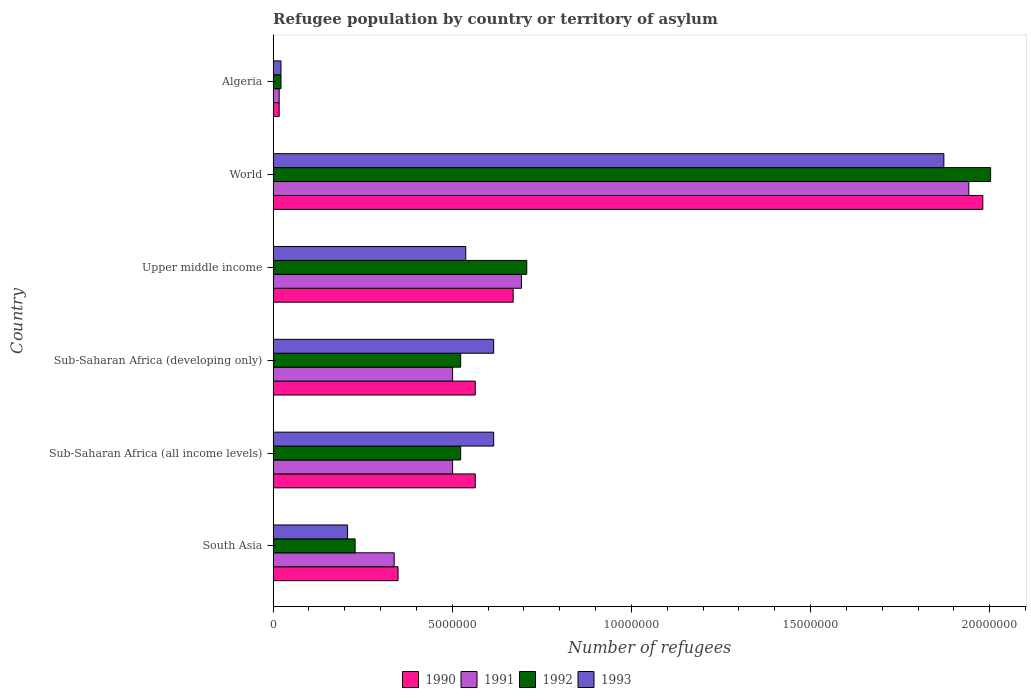How many different coloured bars are there?
Provide a short and direct response. 4. Are the number of bars per tick equal to the number of legend labels?
Make the answer very short. Yes. How many bars are there on the 2nd tick from the top?
Give a very brief answer. 4. How many bars are there on the 5th tick from the bottom?
Provide a short and direct response. 4. What is the label of the 1st group of bars from the top?
Your answer should be compact. Algeria. In how many cases, is the number of bars for a given country not equal to the number of legend labels?
Provide a succinct answer. 0. What is the number of refugees in 1991 in Sub-Saharan Africa (all income levels)?
Offer a very short reply. 5.01e+06. Across all countries, what is the maximum number of refugees in 1990?
Offer a very short reply. 1.98e+07. Across all countries, what is the minimum number of refugees in 1992?
Provide a succinct answer. 2.19e+05. In which country was the number of refugees in 1993 minimum?
Make the answer very short. Algeria. What is the total number of refugees in 1993 in the graph?
Provide a short and direct response. 3.87e+07. What is the difference between the number of refugees in 1993 in Sub-Saharan Africa (all income levels) and that in World?
Keep it short and to the point. -1.26e+07. What is the difference between the number of refugees in 1991 in Sub-Saharan Africa (all income levels) and the number of refugees in 1993 in Upper middle income?
Offer a terse response. -3.67e+05. What is the average number of refugees in 1993 per country?
Make the answer very short. 6.45e+06. In how many countries, is the number of refugees in 1992 greater than 13000000 ?
Give a very brief answer. 1. What is the ratio of the number of refugees in 1992 in Algeria to that in South Asia?
Give a very brief answer. 0.1. Is the number of refugees in 1992 in Algeria less than that in South Asia?
Offer a terse response. Yes. Is the difference between the number of refugees in 1991 in Sub-Saharan Africa (all income levels) and Sub-Saharan Africa (developing only) greater than the difference between the number of refugees in 1990 in Sub-Saharan Africa (all income levels) and Sub-Saharan Africa (developing only)?
Your response must be concise. No. What is the difference between the highest and the second highest number of refugees in 1990?
Your response must be concise. 1.31e+07. What is the difference between the highest and the lowest number of refugees in 1991?
Your answer should be compact. 1.92e+07. Is it the case that in every country, the sum of the number of refugees in 1992 and number of refugees in 1993 is greater than the number of refugees in 1990?
Your response must be concise. Yes. How many bars are there?
Provide a short and direct response. 24. Are all the bars in the graph horizontal?
Ensure brevity in your answer.  Yes. How many countries are there in the graph?
Provide a short and direct response. 6. Are the values on the major ticks of X-axis written in scientific E-notation?
Provide a succinct answer. No. Does the graph contain any zero values?
Make the answer very short. No. Does the graph contain grids?
Give a very brief answer. No. What is the title of the graph?
Ensure brevity in your answer.  Refugee population by country or territory of asylum. What is the label or title of the X-axis?
Provide a succinct answer. Number of refugees. What is the label or title of the Y-axis?
Offer a terse response. Country. What is the Number of refugees of 1990 in South Asia?
Make the answer very short. 3.49e+06. What is the Number of refugees in 1991 in South Asia?
Offer a very short reply. 3.38e+06. What is the Number of refugees in 1992 in South Asia?
Provide a short and direct response. 2.29e+06. What is the Number of refugees in 1993 in South Asia?
Provide a short and direct response. 2.08e+06. What is the Number of refugees of 1990 in Sub-Saharan Africa (all income levels)?
Give a very brief answer. 5.64e+06. What is the Number of refugees of 1991 in Sub-Saharan Africa (all income levels)?
Ensure brevity in your answer.  5.01e+06. What is the Number of refugees in 1992 in Sub-Saharan Africa (all income levels)?
Keep it short and to the point. 5.23e+06. What is the Number of refugees of 1993 in Sub-Saharan Africa (all income levels)?
Your answer should be compact. 6.16e+06. What is the Number of refugees in 1990 in Sub-Saharan Africa (developing only)?
Give a very brief answer. 5.64e+06. What is the Number of refugees in 1991 in Sub-Saharan Africa (developing only)?
Provide a short and direct response. 5.01e+06. What is the Number of refugees in 1992 in Sub-Saharan Africa (developing only)?
Your response must be concise. 5.23e+06. What is the Number of refugees of 1993 in Sub-Saharan Africa (developing only)?
Your response must be concise. 6.16e+06. What is the Number of refugees in 1990 in Upper middle income?
Your answer should be compact. 6.70e+06. What is the Number of refugees in 1991 in Upper middle income?
Provide a short and direct response. 6.93e+06. What is the Number of refugees of 1992 in Upper middle income?
Ensure brevity in your answer.  7.08e+06. What is the Number of refugees in 1993 in Upper middle income?
Keep it short and to the point. 5.38e+06. What is the Number of refugees of 1990 in World?
Ensure brevity in your answer.  1.98e+07. What is the Number of refugees in 1991 in World?
Ensure brevity in your answer.  1.94e+07. What is the Number of refugees in 1992 in World?
Provide a short and direct response. 2.00e+07. What is the Number of refugees in 1993 in World?
Offer a terse response. 1.87e+07. What is the Number of refugees in 1990 in Algeria?
Ensure brevity in your answer.  1.69e+05. What is the Number of refugees in 1991 in Algeria?
Offer a very short reply. 1.69e+05. What is the Number of refugees of 1992 in Algeria?
Make the answer very short. 2.19e+05. What is the Number of refugees in 1993 in Algeria?
Your response must be concise. 2.19e+05. Across all countries, what is the maximum Number of refugees of 1990?
Make the answer very short. 1.98e+07. Across all countries, what is the maximum Number of refugees in 1991?
Offer a very short reply. 1.94e+07. Across all countries, what is the maximum Number of refugees in 1992?
Your response must be concise. 2.00e+07. Across all countries, what is the maximum Number of refugees of 1993?
Provide a succinct answer. 1.87e+07. Across all countries, what is the minimum Number of refugees in 1990?
Offer a very short reply. 1.69e+05. Across all countries, what is the minimum Number of refugees of 1991?
Your answer should be compact. 1.69e+05. Across all countries, what is the minimum Number of refugees in 1992?
Keep it short and to the point. 2.19e+05. Across all countries, what is the minimum Number of refugees of 1993?
Your answer should be very brief. 2.19e+05. What is the total Number of refugees in 1990 in the graph?
Offer a terse response. 4.14e+07. What is the total Number of refugees in 1991 in the graph?
Give a very brief answer. 3.99e+07. What is the total Number of refugees in 1992 in the graph?
Your answer should be very brief. 4.01e+07. What is the total Number of refugees of 1993 in the graph?
Provide a succinct answer. 3.87e+07. What is the difference between the Number of refugees in 1990 in South Asia and that in Sub-Saharan Africa (all income levels)?
Provide a short and direct response. -2.15e+06. What is the difference between the Number of refugees of 1991 in South Asia and that in Sub-Saharan Africa (all income levels)?
Your response must be concise. -1.63e+06. What is the difference between the Number of refugees in 1992 in South Asia and that in Sub-Saharan Africa (all income levels)?
Offer a very short reply. -2.95e+06. What is the difference between the Number of refugees in 1993 in South Asia and that in Sub-Saharan Africa (all income levels)?
Keep it short and to the point. -4.08e+06. What is the difference between the Number of refugees of 1990 in South Asia and that in Sub-Saharan Africa (developing only)?
Make the answer very short. -2.15e+06. What is the difference between the Number of refugees of 1991 in South Asia and that in Sub-Saharan Africa (developing only)?
Your answer should be compact. -1.63e+06. What is the difference between the Number of refugees of 1992 in South Asia and that in Sub-Saharan Africa (developing only)?
Ensure brevity in your answer.  -2.95e+06. What is the difference between the Number of refugees in 1993 in South Asia and that in Sub-Saharan Africa (developing only)?
Your answer should be very brief. -4.08e+06. What is the difference between the Number of refugees in 1990 in South Asia and that in Upper middle income?
Your response must be concise. -3.21e+06. What is the difference between the Number of refugees in 1991 in South Asia and that in Upper middle income?
Keep it short and to the point. -3.55e+06. What is the difference between the Number of refugees in 1992 in South Asia and that in Upper middle income?
Offer a terse response. -4.79e+06. What is the difference between the Number of refugees of 1993 in South Asia and that in Upper middle income?
Provide a succinct answer. -3.30e+06. What is the difference between the Number of refugees in 1990 in South Asia and that in World?
Your response must be concise. -1.63e+07. What is the difference between the Number of refugees of 1991 in South Asia and that in World?
Provide a succinct answer. -1.60e+07. What is the difference between the Number of refugees of 1992 in South Asia and that in World?
Your answer should be compact. -1.77e+07. What is the difference between the Number of refugees in 1993 in South Asia and that in World?
Provide a short and direct response. -1.66e+07. What is the difference between the Number of refugees of 1990 in South Asia and that in Algeria?
Your answer should be very brief. 3.32e+06. What is the difference between the Number of refugees in 1991 in South Asia and that in Algeria?
Your response must be concise. 3.21e+06. What is the difference between the Number of refugees of 1992 in South Asia and that in Algeria?
Provide a short and direct response. 2.07e+06. What is the difference between the Number of refugees in 1993 in South Asia and that in Algeria?
Your answer should be very brief. 1.86e+06. What is the difference between the Number of refugees of 1990 in Sub-Saharan Africa (all income levels) and that in Sub-Saharan Africa (developing only)?
Ensure brevity in your answer.  0. What is the difference between the Number of refugees in 1992 in Sub-Saharan Africa (all income levels) and that in Sub-Saharan Africa (developing only)?
Give a very brief answer. 0. What is the difference between the Number of refugees in 1993 in Sub-Saharan Africa (all income levels) and that in Sub-Saharan Africa (developing only)?
Your answer should be compact. 0. What is the difference between the Number of refugees in 1990 in Sub-Saharan Africa (all income levels) and that in Upper middle income?
Your answer should be very brief. -1.06e+06. What is the difference between the Number of refugees of 1991 in Sub-Saharan Africa (all income levels) and that in Upper middle income?
Provide a short and direct response. -1.92e+06. What is the difference between the Number of refugees of 1992 in Sub-Saharan Africa (all income levels) and that in Upper middle income?
Your response must be concise. -1.84e+06. What is the difference between the Number of refugees in 1993 in Sub-Saharan Africa (all income levels) and that in Upper middle income?
Provide a succinct answer. 7.79e+05. What is the difference between the Number of refugees of 1990 in Sub-Saharan Africa (all income levels) and that in World?
Your answer should be very brief. -1.42e+07. What is the difference between the Number of refugees of 1991 in Sub-Saharan Africa (all income levels) and that in World?
Give a very brief answer. -1.44e+07. What is the difference between the Number of refugees in 1992 in Sub-Saharan Africa (all income levels) and that in World?
Provide a short and direct response. -1.48e+07. What is the difference between the Number of refugees in 1993 in Sub-Saharan Africa (all income levels) and that in World?
Provide a succinct answer. -1.26e+07. What is the difference between the Number of refugees in 1990 in Sub-Saharan Africa (all income levels) and that in Algeria?
Provide a succinct answer. 5.47e+06. What is the difference between the Number of refugees in 1991 in Sub-Saharan Africa (all income levels) and that in Algeria?
Make the answer very short. 4.84e+06. What is the difference between the Number of refugees in 1992 in Sub-Saharan Africa (all income levels) and that in Algeria?
Give a very brief answer. 5.01e+06. What is the difference between the Number of refugees in 1993 in Sub-Saharan Africa (all income levels) and that in Algeria?
Give a very brief answer. 5.94e+06. What is the difference between the Number of refugees of 1990 in Sub-Saharan Africa (developing only) and that in Upper middle income?
Keep it short and to the point. -1.06e+06. What is the difference between the Number of refugees of 1991 in Sub-Saharan Africa (developing only) and that in Upper middle income?
Keep it short and to the point. -1.92e+06. What is the difference between the Number of refugees of 1992 in Sub-Saharan Africa (developing only) and that in Upper middle income?
Give a very brief answer. -1.84e+06. What is the difference between the Number of refugees in 1993 in Sub-Saharan Africa (developing only) and that in Upper middle income?
Give a very brief answer. 7.79e+05. What is the difference between the Number of refugees of 1990 in Sub-Saharan Africa (developing only) and that in World?
Offer a very short reply. -1.42e+07. What is the difference between the Number of refugees in 1991 in Sub-Saharan Africa (developing only) and that in World?
Provide a succinct answer. -1.44e+07. What is the difference between the Number of refugees in 1992 in Sub-Saharan Africa (developing only) and that in World?
Your answer should be very brief. -1.48e+07. What is the difference between the Number of refugees of 1993 in Sub-Saharan Africa (developing only) and that in World?
Provide a succinct answer. -1.26e+07. What is the difference between the Number of refugees in 1990 in Sub-Saharan Africa (developing only) and that in Algeria?
Provide a succinct answer. 5.47e+06. What is the difference between the Number of refugees of 1991 in Sub-Saharan Africa (developing only) and that in Algeria?
Provide a short and direct response. 4.84e+06. What is the difference between the Number of refugees in 1992 in Sub-Saharan Africa (developing only) and that in Algeria?
Keep it short and to the point. 5.01e+06. What is the difference between the Number of refugees in 1993 in Sub-Saharan Africa (developing only) and that in Algeria?
Offer a very short reply. 5.94e+06. What is the difference between the Number of refugees of 1990 in Upper middle income and that in World?
Make the answer very short. -1.31e+07. What is the difference between the Number of refugees of 1991 in Upper middle income and that in World?
Ensure brevity in your answer.  -1.25e+07. What is the difference between the Number of refugees in 1992 in Upper middle income and that in World?
Your answer should be very brief. -1.29e+07. What is the difference between the Number of refugees in 1993 in Upper middle income and that in World?
Your answer should be compact. -1.33e+07. What is the difference between the Number of refugees of 1990 in Upper middle income and that in Algeria?
Provide a succinct answer. 6.53e+06. What is the difference between the Number of refugees of 1991 in Upper middle income and that in Algeria?
Ensure brevity in your answer.  6.76e+06. What is the difference between the Number of refugees in 1992 in Upper middle income and that in Algeria?
Your answer should be compact. 6.86e+06. What is the difference between the Number of refugees of 1993 in Upper middle income and that in Algeria?
Offer a very short reply. 5.16e+06. What is the difference between the Number of refugees in 1990 in World and that in Algeria?
Keep it short and to the point. 1.96e+07. What is the difference between the Number of refugees in 1991 in World and that in Algeria?
Offer a very short reply. 1.92e+07. What is the difference between the Number of refugees in 1992 in World and that in Algeria?
Offer a very short reply. 1.98e+07. What is the difference between the Number of refugees in 1993 in World and that in Algeria?
Your answer should be very brief. 1.85e+07. What is the difference between the Number of refugees of 1990 in South Asia and the Number of refugees of 1991 in Sub-Saharan Africa (all income levels)?
Ensure brevity in your answer.  -1.52e+06. What is the difference between the Number of refugees in 1990 in South Asia and the Number of refugees in 1992 in Sub-Saharan Africa (all income levels)?
Give a very brief answer. -1.75e+06. What is the difference between the Number of refugees in 1990 in South Asia and the Number of refugees in 1993 in Sub-Saharan Africa (all income levels)?
Your response must be concise. -2.67e+06. What is the difference between the Number of refugees of 1991 in South Asia and the Number of refugees of 1992 in Sub-Saharan Africa (all income levels)?
Your answer should be compact. -1.86e+06. What is the difference between the Number of refugees in 1991 in South Asia and the Number of refugees in 1993 in Sub-Saharan Africa (all income levels)?
Keep it short and to the point. -2.78e+06. What is the difference between the Number of refugees of 1992 in South Asia and the Number of refugees of 1993 in Sub-Saharan Africa (all income levels)?
Make the answer very short. -3.87e+06. What is the difference between the Number of refugees of 1990 in South Asia and the Number of refugees of 1991 in Sub-Saharan Africa (developing only)?
Your answer should be compact. -1.52e+06. What is the difference between the Number of refugees in 1990 in South Asia and the Number of refugees in 1992 in Sub-Saharan Africa (developing only)?
Keep it short and to the point. -1.75e+06. What is the difference between the Number of refugees in 1990 in South Asia and the Number of refugees in 1993 in Sub-Saharan Africa (developing only)?
Your answer should be compact. -2.67e+06. What is the difference between the Number of refugees of 1991 in South Asia and the Number of refugees of 1992 in Sub-Saharan Africa (developing only)?
Provide a short and direct response. -1.86e+06. What is the difference between the Number of refugees in 1991 in South Asia and the Number of refugees in 1993 in Sub-Saharan Africa (developing only)?
Give a very brief answer. -2.78e+06. What is the difference between the Number of refugees in 1992 in South Asia and the Number of refugees in 1993 in Sub-Saharan Africa (developing only)?
Provide a short and direct response. -3.87e+06. What is the difference between the Number of refugees in 1990 in South Asia and the Number of refugees in 1991 in Upper middle income?
Make the answer very short. -3.44e+06. What is the difference between the Number of refugees in 1990 in South Asia and the Number of refugees in 1992 in Upper middle income?
Offer a terse response. -3.59e+06. What is the difference between the Number of refugees of 1990 in South Asia and the Number of refugees of 1993 in Upper middle income?
Your answer should be very brief. -1.89e+06. What is the difference between the Number of refugees in 1991 in South Asia and the Number of refugees in 1992 in Upper middle income?
Offer a very short reply. -3.70e+06. What is the difference between the Number of refugees in 1991 in South Asia and the Number of refugees in 1993 in Upper middle income?
Provide a short and direct response. -2.00e+06. What is the difference between the Number of refugees in 1992 in South Asia and the Number of refugees in 1993 in Upper middle income?
Your answer should be very brief. -3.09e+06. What is the difference between the Number of refugees of 1990 in South Asia and the Number of refugees of 1991 in World?
Provide a short and direct response. -1.59e+07. What is the difference between the Number of refugees of 1990 in South Asia and the Number of refugees of 1992 in World?
Your response must be concise. -1.65e+07. What is the difference between the Number of refugees in 1990 in South Asia and the Number of refugees in 1993 in World?
Offer a very short reply. -1.52e+07. What is the difference between the Number of refugees in 1991 in South Asia and the Number of refugees in 1992 in World?
Your answer should be very brief. -1.66e+07. What is the difference between the Number of refugees in 1991 in South Asia and the Number of refugees in 1993 in World?
Offer a terse response. -1.53e+07. What is the difference between the Number of refugees in 1992 in South Asia and the Number of refugees in 1993 in World?
Your answer should be compact. -1.64e+07. What is the difference between the Number of refugees of 1990 in South Asia and the Number of refugees of 1991 in Algeria?
Provide a succinct answer. 3.32e+06. What is the difference between the Number of refugees in 1990 in South Asia and the Number of refugees in 1992 in Algeria?
Offer a very short reply. 3.27e+06. What is the difference between the Number of refugees of 1990 in South Asia and the Number of refugees of 1993 in Algeria?
Give a very brief answer. 3.27e+06. What is the difference between the Number of refugees of 1991 in South Asia and the Number of refugees of 1992 in Algeria?
Provide a succinct answer. 3.16e+06. What is the difference between the Number of refugees of 1991 in South Asia and the Number of refugees of 1993 in Algeria?
Ensure brevity in your answer.  3.16e+06. What is the difference between the Number of refugees in 1992 in South Asia and the Number of refugees in 1993 in Algeria?
Offer a very short reply. 2.07e+06. What is the difference between the Number of refugees of 1990 in Sub-Saharan Africa (all income levels) and the Number of refugees of 1991 in Sub-Saharan Africa (developing only)?
Give a very brief answer. 6.33e+05. What is the difference between the Number of refugees in 1990 in Sub-Saharan Africa (all income levels) and the Number of refugees in 1992 in Sub-Saharan Africa (developing only)?
Give a very brief answer. 4.07e+05. What is the difference between the Number of refugees of 1990 in Sub-Saharan Africa (all income levels) and the Number of refugees of 1993 in Sub-Saharan Africa (developing only)?
Offer a terse response. -5.14e+05. What is the difference between the Number of refugees of 1991 in Sub-Saharan Africa (all income levels) and the Number of refugees of 1992 in Sub-Saharan Africa (developing only)?
Keep it short and to the point. -2.25e+05. What is the difference between the Number of refugees in 1991 in Sub-Saharan Africa (all income levels) and the Number of refugees in 1993 in Sub-Saharan Africa (developing only)?
Your answer should be compact. -1.15e+06. What is the difference between the Number of refugees in 1992 in Sub-Saharan Africa (all income levels) and the Number of refugees in 1993 in Sub-Saharan Africa (developing only)?
Provide a short and direct response. -9.21e+05. What is the difference between the Number of refugees in 1990 in Sub-Saharan Africa (all income levels) and the Number of refugees in 1991 in Upper middle income?
Provide a succinct answer. -1.29e+06. What is the difference between the Number of refugees of 1990 in Sub-Saharan Africa (all income levels) and the Number of refugees of 1992 in Upper middle income?
Give a very brief answer. -1.44e+06. What is the difference between the Number of refugees in 1990 in Sub-Saharan Africa (all income levels) and the Number of refugees in 1993 in Upper middle income?
Give a very brief answer. 2.65e+05. What is the difference between the Number of refugees of 1991 in Sub-Saharan Africa (all income levels) and the Number of refugees of 1992 in Upper middle income?
Offer a terse response. -2.07e+06. What is the difference between the Number of refugees in 1991 in Sub-Saharan Africa (all income levels) and the Number of refugees in 1993 in Upper middle income?
Your response must be concise. -3.67e+05. What is the difference between the Number of refugees in 1992 in Sub-Saharan Africa (all income levels) and the Number of refugees in 1993 in Upper middle income?
Provide a succinct answer. -1.42e+05. What is the difference between the Number of refugees in 1990 in Sub-Saharan Africa (all income levels) and the Number of refugees in 1991 in World?
Make the answer very short. -1.38e+07. What is the difference between the Number of refugees in 1990 in Sub-Saharan Africa (all income levels) and the Number of refugees in 1992 in World?
Keep it short and to the point. -1.44e+07. What is the difference between the Number of refugees of 1990 in Sub-Saharan Africa (all income levels) and the Number of refugees of 1993 in World?
Make the answer very short. -1.31e+07. What is the difference between the Number of refugees in 1991 in Sub-Saharan Africa (all income levels) and the Number of refugees in 1992 in World?
Your answer should be compact. -1.50e+07. What is the difference between the Number of refugees in 1991 in Sub-Saharan Africa (all income levels) and the Number of refugees in 1993 in World?
Provide a short and direct response. -1.37e+07. What is the difference between the Number of refugees of 1992 in Sub-Saharan Africa (all income levels) and the Number of refugees of 1993 in World?
Your response must be concise. -1.35e+07. What is the difference between the Number of refugees of 1990 in Sub-Saharan Africa (all income levels) and the Number of refugees of 1991 in Algeria?
Your answer should be compact. 5.47e+06. What is the difference between the Number of refugees in 1990 in Sub-Saharan Africa (all income levels) and the Number of refugees in 1992 in Algeria?
Your response must be concise. 5.42e+06. What is the difference between the Number of refugees in 1990 in Sub-Saharan Africa (all income levels) and the Number of refugees in 1993 in Algeria?
Offer a terse response. 5.42e+06. What is the difference between the Number of refugees in 1991 in Sub-Saharan Africa (all income levels) and the Number of refugees in 1992 in Algeria?
Your answer should be compact. 4.79e+06. What is the difference between the Number of refugees in 1991 in Sub-Saharan Africa (all income levels) and the Number of refugees in 1993 in Algeria?
Your response must be concise. 4.79e+06. What is the difference between the Number of refugees in 1992 in Sub-Saharan Africa (all income levels) and the Number of refugees in 1993 in Algeria?
Keep it short and to the point. 5.02e+06. What is the difference between the Number of refugees in 1990 in Sub-Saharan Africa (developing only) and the Number of refugees in 1991 in Upper middle income?
Your response must be concise. -1.29e+06. What is the difference between the Number of refugees of 1990 in Sub-Saharan Africa (developing only) and the Number of refugees of 1992 in Upper middle income?
Ensure brevity in your answer.  -1.44e+06. What is the difference between the Number of refugees of 1990 in Sub-Saharan Africa (developing only) and the Number of refugees of 1993 in Upper middle income?
Your answer should be very brief. 2.65e+05. What is the difference between the Number of refugees of 1991 in Sub-Saharan Africa (developing only) and the Number of refugees of 1992 in Upper middle income?
Provide a short and direct response. -2.07e+06. What is the difference between the Number of refugees in 1991 in Sub-Saharan Africa (developing only) and the Number of refugees in 1993 in Upper middle income?
Offer a very short reply. -3.67e+05. What is the difference between the Number of refugees in 1992 in Sub-Saharan Africa (developing only) and the Number of refugees in 1993 in Upper middle income?
Ensure brevity in your answer.  -1.42e+05. What is the difference between the Number of refugees in 1990 in Sub-Saharan Africa (developing only) and the Number of refugees in 1991 in World?
Offer a terse response. -1.38e+07. What is the difference between the Number of refugees in 1990 in Sub-Saharan Africa (developing only) and the Number of refugees in 1992 in World?
Your answer should be very brief. -1.44e+07. What is the difference between the Number of refugees of 1990 in Sub-Saharan Africa (developing only) and the Number of refugees of 1993 in World?
Offer a very short reply. -1.31e+07. What is the difference between the Number of refugees in 1991 in Sub-Saharan Africa (developing only) and the Number of refugees in 1992 in World?
Give a very brief answer. -1.50e+07. What is the difference between the Number of refugees of 1991 in Sub-Saharan Africa (developing only) and the Number of refugees of 1993 in World?
Give a very brief answer. -1.37e+07. What is the difference between the Number of refugees of 1992 in Sub-Saharan Africa (developing only) and the Number of refugees of 1993 in World?
Offer a very short reply. -1.35e+07. What is the difference between the Number of refugees of 1990 in Sub-Saharan Africa (developing only) and the Number of refugees of 1991 in Algeria?
Give a very brief answer. 5.47e+06. What is the difference between the Number of refugees of 1990 in Sub-Saharan Africa (developing only) and the Number of refugees of 1992 in Algeria?
Make the answer very short. 5.42e+06. What is the difference between the Number of refugees in 1990 in Sub-Saharan Africa (developing only) and the Number of refugees in 1993 in Algeria?
Keep it short and to the point. 5.42e+06. What is the difference between the Number of refugees in 1991 in Sub-Saharan Africa (developing only) and the Number of refugees in 1992 in Algeria?
Ensure brevity in your answer.  4.79e+06. What is the difference between the Number of refugees of 1991 in Sub-Saharan Africa (developing only) and the Number of refugees of 1993 in Algeria?
Your response must be concise. 4.79e+06. What is the difference between the Number of refugees of 1992 in Sub-Saharan Africa (developing only) and the Number of refugees of 1993 in Algeria?
Your response must be concise. 5.02e+06. What is the difference between the Number of refugees of 1990 in Upper middle income and the Number of refugees of 1991 in World?
Offer a terse response. -1.27e+07. What is the difference between the Number of refugees of 1990 in Upper middle income and the Number of refugees of 1992 in World?
Offer a very short reply. -1.33e+07. What is the difference between the Number of refugees of 1990 in Upper middle income and the Number of refugees of 1993 in World?
Offer a very short reply. -1.20e+07. What is the difference between the Number of refugees of 1991 in Upper middle income and the Number of refugees of 1992 in World?
Offer a very short reply. -1.31e+07. What is the difference between the Number of refugees of 1991 in Upper middle income and the Number of refugees of 1993 in World?
Provide a short and direct response. -1.18e+07. What is the difference between the Number of refugees in 1992 in Upper middle income and the Number of refugees in 1993 in World?
Ensure brevity in your answer.  -1.16e+07. What is the difference between the Number of refugees of 1990 in Upper middle income and the Number of refugees of 1991 in Algeria?
Provide a short and direct response. 6.53e+06. What is the difference between the Number of refugees in 1990 in Upper middle income and the Number of refugees in 1992 in Algeria?
Keep it short and to the point. 6.48e+06. What is the difference between the Number of refugees of 1990 in Upper middle income and the Number of refugees of 1993 in Algeria?
Your response must be concise. 6.48e+06. What is the difference between the Number of refugees in 1991 in Upper middle income and the Number of refugees in 1992 in Algeria?
Offer a terse response. 6.71e+06. What is the difference between the Number of refugees in 1991 in Upper middle income and the Number of refugees in 1993 in Algeria?
Give a very brief answer. 6.71e+06. What is the difference between the Number of refugees of 1992 in Upper middle income and the Number of refugees of 1993 in Algeria?
Your answer should be compact. 6.86e+06. What is the difference between the Number of refugees of 1990 in World and the Number of refugees of 1991 in Algeria?
Provide a short and direct response. 1.96e+07. What is the difference between the Number of refugees in 1990 in World and the Number of refugees in 1992 in Algeria?
Offer a terse response. 1.96e+07. What is the difference between the Number of refugees of 1990 in World and the Number of refugees of 1993 in Algeria?
Make the answer very short. 1.96e+07. What is the difference between the Number of refugees in 1991 in World and the Number of refugees in 1992 in Algeria?
Provide a short and direct response. 1.92e+07. What is the difference between the Number of refugees of 1991 in World and the Number of refugees of 1993 in Algeria?
Provide a succinct answer. 1.92e+07. What is the difference between the Number of refugees in 1992 in World and the Number of refugees in 1993 in Algeria?
Make the answer very short. 1.98e+07. What is the average Number of refugees of 1990 per country?
Make the answer very short. 6.91e+06. What is the average Number of refugees of 1991 per country?
Make the answer very short. 6.65e+06. What is the average Number of refugees of 1992 per country?
Your answer should be compact. 6.68e+06. What is the average Number of refugees of 1993 per country?
Your response must be concise. 6.45e+06. What is the difference between the Number of refugees of 1990 and Number of refugees of 1991 in South Asia?
Provide a short and direct response. 1.08e+05. What is the difference between the Number of refugees of 1990 and Number of refugees of 1992 in South Asia?
Offer a terse response. 1.20e+06. What is the difference between the Number of refugees in 1990 and Number of refugees in 1993 in South Asia?
Offer a very short reply. 1.41e+06. What is the difference between the Number of refugees in 1991 and Number of refugees in 1992 in South Asia?
Provide a succinct answer. 1.09e+06. What is the difference between the Number of refugees in 1991 and Number of refugees in 1993 in South Asia?
Your response must be concise. 1.30e+06. What is the difference between the Number of refugees of 1992 and Number of refugees of 1993 in South Asia?
Give a very brief answer. 2.10e+05. What is the difference between the Number of refugees of 1990 and Number of refugees of 1991 in Sub-Saharan Africa (all income levels)?
Keep it short and to the point. 6.33e+05. What is the difference between the Number of refugees in 1990 and Number of refugees in 1992 in Sub-Saharan Africa (all income levels)?
Provide a short and direct response. 4.07e+05. What is the difference between the Number of refugees of 1990 and Number of refugees of 1993 in Sub-Saharan Africa (all income levels)?
Your answer should be very brief. -5.14e+05. What is the difference between the Number of refugees of 1991 and Number of refugees of 1992 in Sub-Saharan Africa (all income levels)?
Provide a succinct answer. -2.25e+05. What is the difference between the Number of refugees in 1991 and Number of refugees in 1993 in Sub-Saharan Africa (all income levels)?
Your response must be concise. -1.15e+06. What is the difference between the Number of refugees in 1992 and Number of refugees in 1993 in Sub-Saharan Africa (all income levels)?
Keep it short and to the point. -9.21e+05. What is the difference between the Number of refugees of 1990 and Number of refugees of 1991 in Sub-Saharan Africa (developing only)?
Your response must be concise. 6.33e+05. What is the difference between the Number of refugees in 1990 and Number of refugees in 1992 in Sub-Saharan Africa (developing only)?
Keep it short and to the point. 4.07e+05. What is the difference between the Number of refugees of 1990 and Number of refugees of 1993 in Sub-Saharan Africa (developing only)?
Make the answer very short. -5.14e+05. What is the difference between the Number of refugees of 1991 and Number of refugees of 1992 in Sub-Saharan Africa (developing only)?
Offer a very short reply. -2.25e+05. What is the difference between the Number of refugees in 1991 and Number of refugees in 1993 in Sub-Saharan Africa (developing only)?
Your answer should be very brief. -1.15e+06. What is the difference between the Number of refugees of 1992 and Number of refugees of 1993 in Sub-Saharan Africa (developing only)?
Keep it short and to the point. -9.21e+05. What is the difference between the Number of refugees in 1990 and Number of refugees in 1991 in Upper middle income?
Ensure brevity in your answer.  -2.32e+05. What is the difference between the Number of refugees in 1990 and Number of refugees in 1992 in Upper middle income?
Keep it short and to the point. -3.79e+05. What is the difference between the Number of refugees in 1990 and Number of refugees in 1993 in Upper middle income?
Provide a short and direct response. 1.32e+06. What is the difference between the Number of refugees of 1991 and Number of refugees of 1992 in Upper middle income?
Offer a very short reply. -1.47e+05. What is the difference between the Number of refugees of 1991 and Number of refugees of 1993 in Upper middle income?
Make the answer very short. 1.56e+06. What is the difference between the Number of refugees in 1992 and Number of refugees in 1993 in Upper middle income?
Offer a very short reply. 1.70e+06. What is the difference between the Number of refugees of 1990 and Number of refugees of 1991 in World?
Keep it short and to the point. 3.91e+05. What is the difference between the Number of refugees in 1990 and Number of refugees in 1992 in World?
Your response must be concise. -2.18e+05. What is the difference between the Number of refugees in 1990 and Number of refugees in 1993 in World?
Provide a short and direct response. 1.09e+06. What is the difference between the Number of refugees of 1991 and Number of refugees of 1992 in World?
Offer a very short reply. -6.09e+05. What is the difference between the Number of refugees in 1991 and Number of refugees in 1993 in World?
Provide a short and direct response. 6.96e+05. What is the difference between the Number of refugees of 1992 and Number of refugees of 1993 in World?
Keep it short and to the point. 1.30e+06. What is the difference between the Number of refugees of 1990 and Number of refugees of 1991 in Algeria?
Keep it short and to the point. -14. What is the difference between the Number of refugees in 1990 and Number of refugees in 1992 in Algeria?
Keep it short and to the point. -5.02e+04. What is the difference between the Number of refugees of 1990 and Number of refugees of 1993 in Algeria?
Your answer should be very brief. -5.00e+04. What is the difference between the Number of refugees in 1991 and Number of refugees in 1992 in Algeria?
Keep it short and to the point. -5.02e+04. What is the difference between the Number of refugees in 1991 and Number of refugees in 1993 in Algeria?
Your response must be concise. -4.99e+04. What is the difference between the Number of refugees in 1992 and Number of refugees in 1993 in Algeria?
Offer a terse response. 247. What is the ratio of the Number of refugees of 1990 in South Asia to that in Sub-Saharan Africa (all income levels)?
Provide a succinct answer. 0.62. What is the ratio of the Number of refugees in 1991 in South Asia to that in Sub-Saharan Africa (all income levels)?
Make the answer very short. 0.67. What is the ratio of the Number of refugees of 1992 in South Asia to that in Sub-Saharan Africa (all income levels)?
Provide a succinct answer. 0.44. What is the ratio of the Number of refugees in 1993 in South Asia to that in Sub-Saharan Africa (all income levels)?
Ensure brevity in your answer.  0.34. What is the ratio of the Number of refugees of 1990 in South Asia to that in Sub-Saharan Africa (developing only)?
Your response must be concise. 0.62. What is the ratio of the Number of refugees of 1991 in South Asia to that in Sub-Saharan Africa (developing only)?
Your answer should be very brief. 0.67. What is the ratio of the Number of refugees in 1992 in South Asia to that in Sub-Saharan Africa (developing only)?
Provide a succinct answer. 0.44. What is the ratio of the Number of refugees of 1993 in South Asia to that in Sub-Saharan Africa (developing only)?
Offer a very short reply. 0.34. What is the ratio of the Number of refugees of 1990 in South Asia to that in Upper middle income?
Make the answer very short. 0.52. What is the ratio of the Number of refugees of 1991 in South Asia to that in Upper middle income?
Your response must be concise. 0.49. What is the ratio of the Number of refugees of 1992 in South Asia to that in Upper middle income?
Your answer should be compact. 0.32. What is the ratio of the Number of refugees of 1993 in South Asia to that in Upper middle income?
Offer a very short reply. 0.39. What is the ratio of the Number of refugees in 1990 in South Asia to that in World?
Your response must be concise. 0.18. What is the ratio of the Number of refugees in 1991 in South Asia to that in World?
Ensure brevity in your answer.  0.17. What is the ratio of the Number of refugees in 1992 in South Asia to that in World?
Offer a terse response. 0.11. What is the ratio of the Number of refugees of 1993 in South Asia to that in World?
Keep it short and to the point. 0.11. What is the ratio of the Number of refugees in 1990 in South Asia to that in Algeria?
Offer a terse response. 20.62. What is the ratio of the Number of refugees of 1991 in South Asia to that in Algeria?
Your answer should be compact. 19.98. What is the ratio of the Number of refugees in 1992 in South Asia to that in Algeria?
Give a very brief answer. 10.43. What is the ratio of the Number of refugees in 1993 in South Asia to that in Algeria?
Give a very brief answer. 9.49. What is the ratio of the Number of refugees of 1992 in Sub-Saharan Africa (all income levels) to that in Sub-Saharan Africa (developing only)?
Offer a terse response. 1. What is the ratio of the Number of refugees in 1990 in Sub-Saharan Africa (all income levels) to that in Upper middle income?
Your answer should be very brief. 0.84. What is the ratio of the Number of refugees in 1991 in Sub-Saharan Africa (all income levels) to that in Upper middle income?
Your answer should be compact. 0.72. What is the ratio of the Number of refugees of 1992 in Sub-Saharan Africa (all income levels) to that in Upper middle income?
Offer a very short reply. 0.74. What is the ratio of the Number of refugees in 1993 in Sub-Saharan Africa (all income levels) to that in Upper middle income?
Offer a very short reply. 1.15. What is the ratio of the Number of refugees of 1990 in Sub-Saharan Africa (all income levels) to that in World?
Provide a succinct answer. 0.28. What is the ratio of the Number of refugees of 1991 in Sub-Saharan Africa (all income levels) to that in World?
Your answer should be very brief. 0.26. What is the ratio of the Number of refugees in 1992 in Sub-Saharan Africa (all income levels) to that in World?
Give a very brief answer. 0.26. What is the ratio of the Number of refugees of 1993 in Sub-Saharan Africa (all income levels) to that in World?
Offer a very short reply. 0.33. What is the ratio of the Number of refugees of 1990 in Sub-Saharan Africa (all income levels) to that in Algeria?
Make the answer very short. 33.36. What is the ratio of the Number of refugees in 1991 in Sub-Saharan Africa (all income levels) to that in Algeria?
Offer a very short reply. 29.62. What is the ratio of the Number of refugees of 1992 in Sub-Saharan Africa (all income levels) to that in Algeria?
Provide a succinct answer. 23.87. What is the ratio of the Number of refugees of 1993 in Sub-Saharan Africa (all income levels) to that in Algeria?
Ensure brevity in your answer.  28.1. What is the ratio of the Number of refugees of 1990 in Sub-Saharan Africa (developing only) to that in Upper middle income?
Provide a succinct answer. 0.84. What is the ratio of the Number of refugees of 1991 in Sub-Saharan Africa (developing only) to that in Upper middle income?
Your response must be concise. 0.72. What is the ratio of the Number of refugees in 1992 in Sub-Saharan Africa (developing only) to that in Upper middle income?
Provide a succinct answer. 0.74. What is the ratio of the Number of refugees in 1993 in Sub-Saharan Africa (developing only) to that in Upper middle income?
Provide a short and direct response. 1.15. What is the ratio of the Number of refugees in 1990 in Sub-Saharan Africa (developing only) to that in World?
Your answer should be very brief. 0.28. What is the ratio of the Number of refugees in 1991 in Sub-Saharan Africa (developing only) to that in World?
Provide a succinct answer. 0.26. What is the ratio of the Number of refugees in 1992 in Sub-Saharan Africa (developing only) to that in World?
Give a very brief answer. 0.26. What is the ratio of the Number of refugees in 1993 in Sub-Saharan Africa (developing only) to that in World?
Keep it short and to the point. 0.33. What is the ratio of the Number of refugees of 1990 in Sub-Saharan Africa (developing only) to that in Algeria?
Provide a short and direct response. 33.36. What is the ratio of the Number of refugees of 1991 in Sub-Saharan Africa (developing only) to that in Algeria?
Your response must be concise. 29.62. What is the ratio of the Number of refugees in 1992 in Sub-Saharan Africa (developing only) to that in Algeria?
Ensure brevity in your answer.  23.87. What is the ratio of the Number of refugees of 1993 in Sub-Saharan Africa (developing only) to that in Algeria?
Provide a short and direct response. 28.1. What is the ratio of the Number of refugees of 1990 in Upper middle income to that in World?
Your answer should be compact. 0.34. What is the ratio of the Number of refugees of 1991 in Upper middle income to that in World?
Your answer should be very brief. 0.36. What is the ratio of the Number of refugees in 1992 in Upper middle income to that in World?
Give a very brief answer. 0.35. What is the ratio of the Number of refugees in 1993 in Upper middle income to that in World?
Offer a terse response. 0.29. What is the ratio of the Number of refugees in 1990 in Upper middle income to that in Algeria?
Your answer should be compact. 39.62. What is the ratio of the Number of refugees in 1991 in Upper middle income to that in Algeria?
Your answer should be compact. 40.98. What is the ratio of the Number of refugees of 1992 in Upper middle income to that in Algeria?
Give a very brief answer. 32.28. What is the ratio of the Number of refugees in 1993 in Upper middle income to that in Algeria?
Your answer should be compact. 24.54. What is the ratio of the Number of refugees in 1990 in World to that in Algeria?
Your answer should be compact. 117.12. What is the ratio of the Number of refugees in 1991 in World to that in Algeria?
Offer a very short reply. 114.8. What is the ratio of the Number of refugees in 1992 in World to that in Algeria?
Your answer should be very brief. 91.3. What is the ratio of the Number of refugees in 1993 in World to that in Algeria?
Make the answer very short. 85.45. What is the difference between the highest and the second highest Number of refugees of 1990?
Your answer should be very brief. 1.31e+07. What is the difference between the highest and the second highest Number of refugees of 1991?
Make the answer very short. 1.25e+07. What is the difference between the highest and the second highest Number of refugees of 1992?
Make the answer very short. 1.29e+07. What is the difference between the highest and the second highest Number of refugees in 1993?
Give a very brief answer. 1.26e+07. What is the difference between the highest and the lowest Number of refugees in 1990?
Your answer should be very brief. 1.96e+07. What is the difference between the highest and the lowest Number of refugees of 1991?
Your answer should be very brief. 1.92e+07. What is the difference between the highest and the lowest Number of refugees of 1992?
Offer a very short reply. 1.98e+07. What is the difference between the highest and the lowest Number of refugees in 1993?
Ensure brevity in your answer.  1.85e+07. 